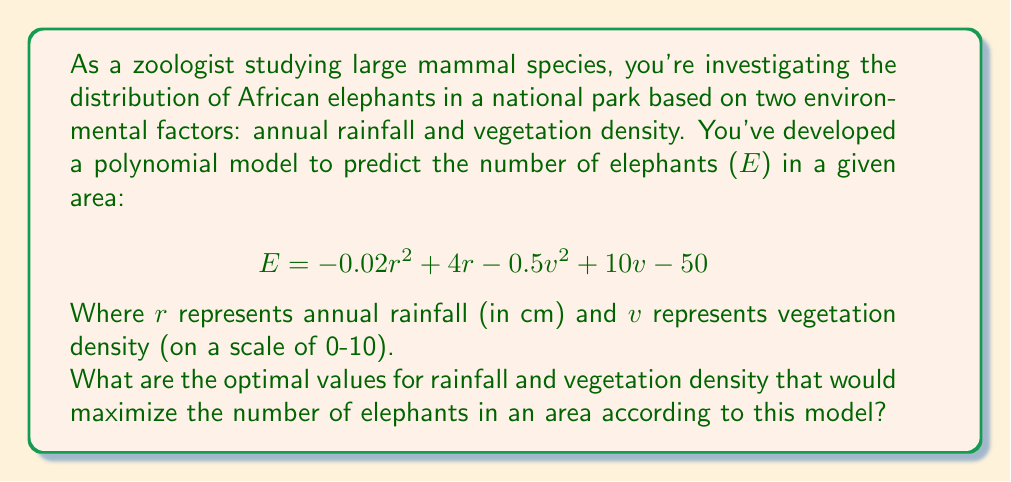What is the answer to this math problem? To find the optimal values for rainfall (r) and vegetation density (v) that maximize the number of elephants (E), we need to find the maximum point of the polynomial function. This can be done by calculating the partial derivatives with respect to r and v, setting them equal to zero, and solving the resulting system of equations.

Step 1: Calculate partial derivatives
$$\frac{\partial E}{\partial r} = -0.04r + 4$$
$$\frac{\partial E}{\partial v} = -v + 10$$

Step 2: Set partial derivatives to zero and solve
$$-0.04r + 4 = 0$$
$$-v + 10 = 0$$

Step 3: Solve for r and v
For r: $$-0.04r = -4$$
$$r = 100$$

For v: $$v = 10$$

Step 4: Verify that this is a maximum point
To confirm this is a maximum point, we can check the second partial derivatives:
$$\frac{\partial^2 E}{\partial r^2} = -0.04 < 0$$
$$\frac{\partial^2 E}{\partial v^2} = -1 < 0$$

Since both second partial derivatives are negative, this confirms that the point (100, 10) is indeed a maximum.

Therefore, the optimal values are:
Annual rainfall (r) = 100 cm
Vegetation density (v) = 10 (on the 0-10 scale)
Answer: r = 100 cm, v = 10 